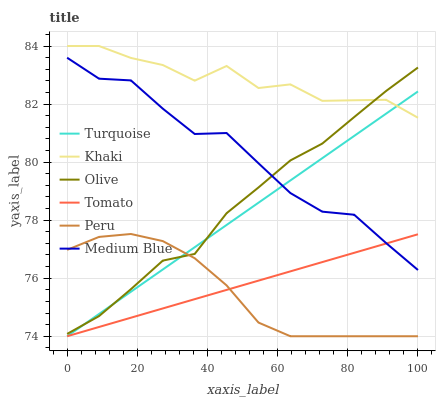Does Peru have the minimum area under the curve?
Answer yes or no. Yes. Does Khaki have the maximum area under the curve?
Answer yes or no. Yes. Does Turquoise have the minimum area under the curve?
Answer yes or no. No. Does Turquoise have the maximum area under the curve?
Answer yes or no. No. Is Turquoise the smoothest?
Answer yes or no. Yes. Is Khaki the roughest?
Answer yes or no. Yes. Is Khaki the smoothest?
Answer yes or no. No. Is Turquoise the roughest?
Answer yes or no. No. Does Tomato have the lowest value?
Answer yes or no. Yes. Does Khaki have the lowest value?
Answer yes or no. No. Does Khaki have the highest value?
Answer yes or no. Yes. Does Turquoise have the highest value?
Answer yes or no. No. Is Tomato less than Khaki?
Answer yes or no. Yes. Is Khaki greater than Medium Blue?
Answer yes or no. Yes. Does Peru intersect Olive?
Answer yes or no. Yes. Is Peru less than Olive?
Answer yes or no. No. Is Peru greater than Olive?
Answer yes or no. No. Does Tomato intersect Khaki?
Answer yes or no. No. 